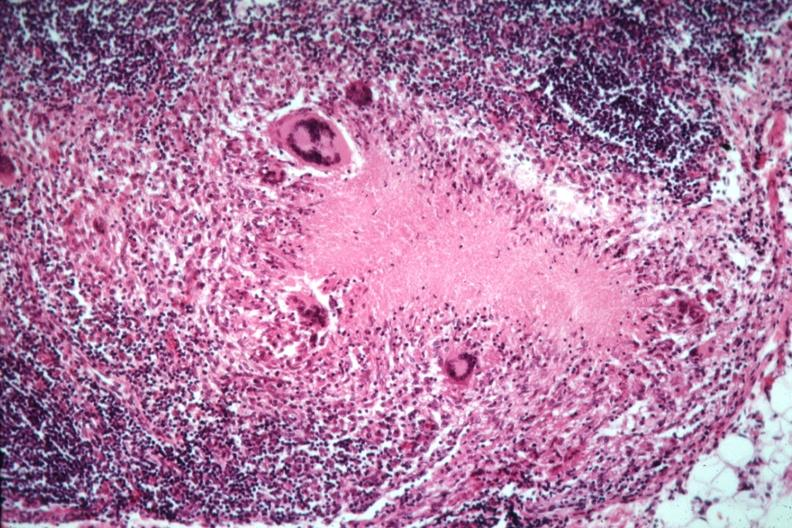does this image show good example necrotizing granuloma with giant cells?
Answer the question using a single word or phrase. Yes 